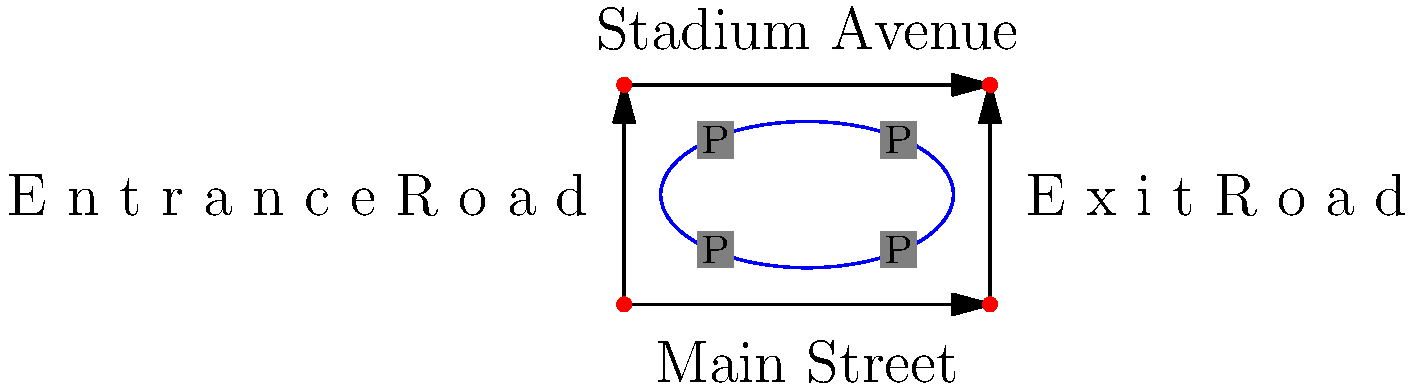As a sports commentator familiar with the Asim Ferhatović Hase Stadium in Sarajevo, you've been asked to consult on a traffic flow optimization project around the complex. Given the diagram of the stadium and surrounding roads, what would be the most effective strategy to reduce congestion during high-attendance matches, considering the nostalgic value of the area? To optimize traffic flow around the sports complex while preserving its nostalgic value, we need to consider several factors:

1. Historical context: The Asim Ferhatović Hase Stadium has significant cultural importance, so any changes should respect its heritage.

2. Current layout: The diagram shows a stadium with four surrounding roads and four parking lots.

3. Traffic flow: The arrows indicate one-way traffic on all roads, which is generally good for reducing congestion.

4. Parking: The four parking lots (P) are strategically placed around the stadium, but may not be sufficient for high-attendance matches.

5. Traffic lights: There are traffic lights at each intersection, which can be used to control traffic flow.

To optimize traffic flow:

a) Implement a smart traffic light system: Use adaptive traffic signals that adjust timing based on real-time traffic conditions. This can help manage the flow of vehicles more efficiently during peak times.

b) Encourage public transportation: Set up dedicated bus lanes on Main Street and Stadium Avenue to prioritize public transit and reduce private vehicle congestion.

c) Utilize park-and-ride systems: Establish remote parking areas with shuttle services to the stadium, reducing the number of cars directly around the complex.

d) Improve pedestrian access: Create safe walkways and overpasses to separate foot traffic from vehicles, enhancing safety and reducing congestion.

e) Implement a one-way system for entrance and exit: Use the Entrance Road exclusively for arriving traffic and the Exit Road for departing vehicles during events.

f) Digital guidance systems: Install electronic signage to direct drivers to available parking spaces and provide real-time traffic information.

g) Preserve nostalgic elements: Maintain the stadium's facade and surrounding historical features while implementing these modern traffic solutions.

By combining these strategies, we can significantly improve traffic flow while maintaining the area's cultural significance.
Answer: Implement smart traffic lights, encourage public transit, use park-and-ride, improve pedestrian access, and add digital guidance while preserving nostalgic elements. 